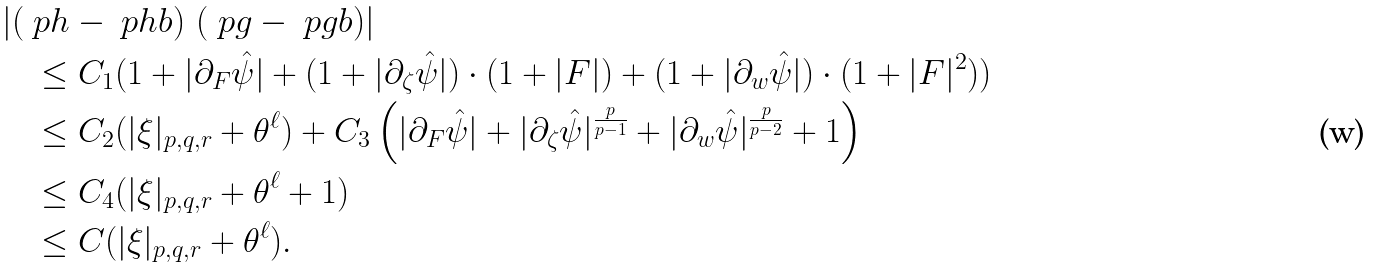Convert formula to latex. <formula><loc_0><loc_0><loc_500><loc_500>& \left | \left ( \ p h - \ p h b \right ) \, \left ( \ p g - \ p g b \right ) \right | \\ & \quad \leq C _ { 1 } ( 1 + | \partial _ { F } \hat { \psi } | + ( 1 + | \partial _ { \zeta } \hat { \psi } | ) \cdot ( 1 + | F | ) + ( 1 + | \partial _ { w } \hat { \psi } | ) \cdot ( 1 + | F | ^ { 2 } ) ) \\ & \quad \leq C _ { 2 } ( | \xi | _ { p , q , r } + \theta ^ { \ell } ) + C _ { 3 } \left ( | \partial _ { F } \hat { \psi } | + | \partial _ { \zeta } \hat { \psi } | ^ { \frac { p } { p - 1 } } + | \partial _ { w } \hat { \psi } | ^ { \frac { p } { p - 2 } } + 1 \right ) \\ & \quad \leq C _ { 4 } ( | \xi | _ { p , q , r } + \theta ^ { \ell } + 1 ) \\ & \quad \leq C ( | \xi | _ { p , q , r } + \theta ^ { \ell } ) .</formula> 